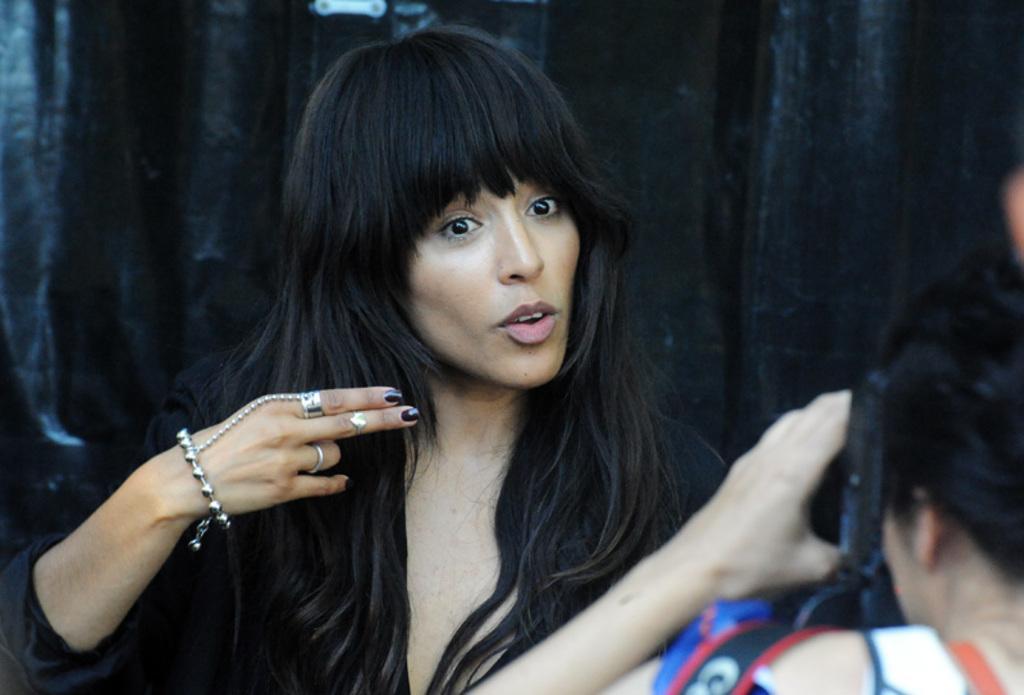How would you summarize this image in a sentence or two? In this image, we can see two people. Here a person is holding a camera. Background there is a black color. 